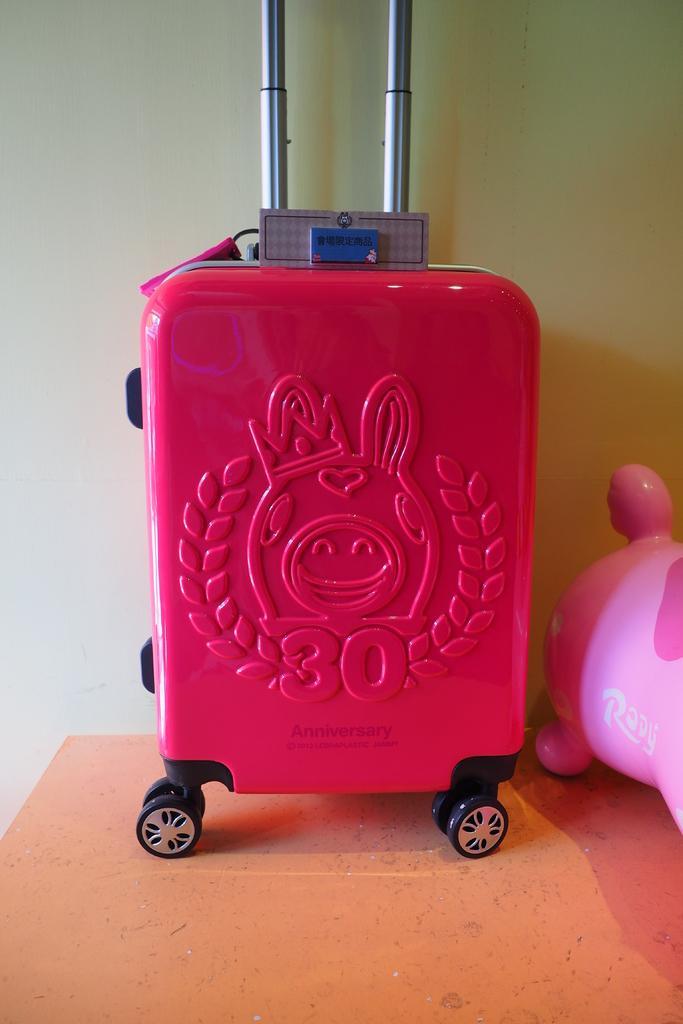Describe this image in one or two sentences. In this image I can see a red color of bag. 